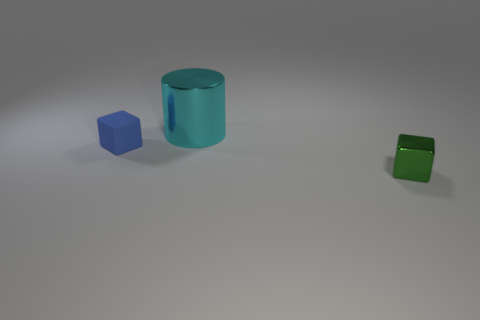There is a small object in front of the cube that is to the left of the metallic thing that is in front of the cyan cylinder; what shape is it?
Give a very brief answer. Cube. Is the number of small shiny objects greater than the number of objects?
Keep it short and to the point. No. What number of other things are the same material as the tiny green cube?
Offer a terse response. 1. How many objects are blue objects or tiny blocks that are behind the green block?
Your answer should be very brief. 1. Are there fewer small purple objects than green things?
Keep it short and to the point. Yes. There is a tiny object in front of the small thing behind the small object right of the blue matte thing; what is its color?
Your answer should be very brief. Green. Are the small green cube and the small blue thing made of the same material?
Offer a very short reply. No. How many things are right of the tiny blue thing?
Provide a succinct answer. 2. How many cyan things are either matte things or metal cylinders?
Keep it short and to the point. 1. There is a small object that is right of the tiny blue rubber thing; what number of tiny blocks are left of it?
Your response must be concise. 1. 